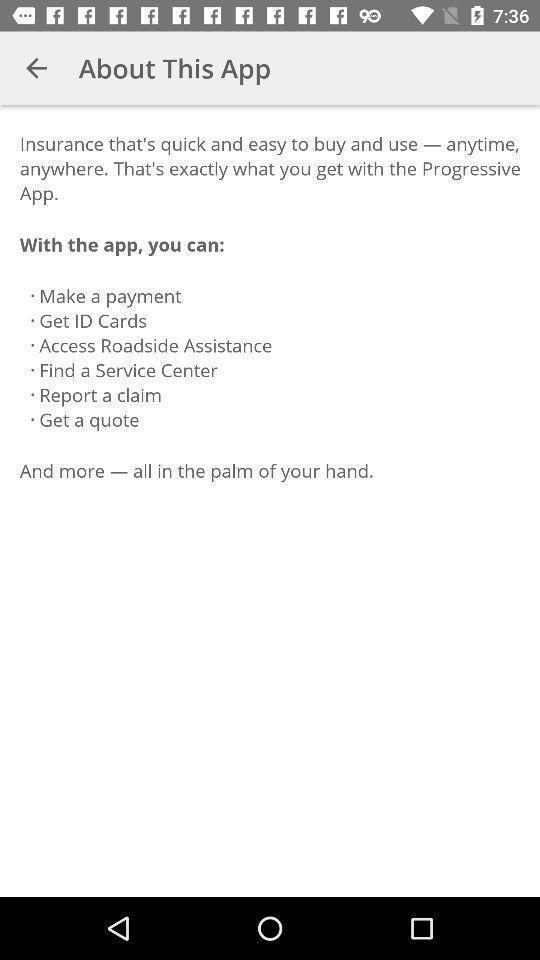Explain what's happening in this screen capture. Screen displaying the features. 